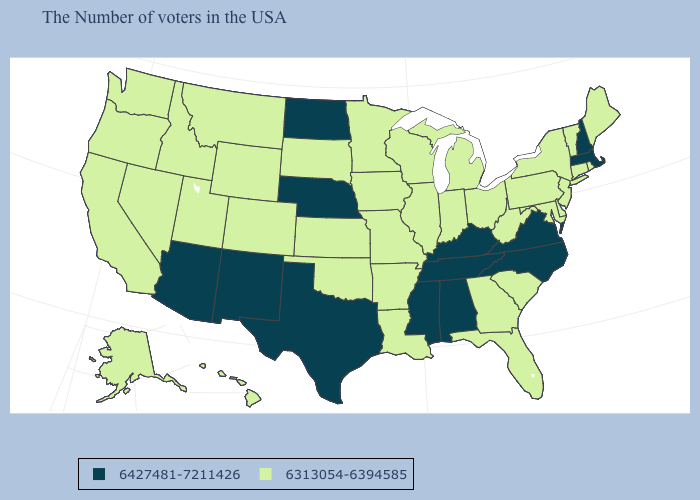Name the states that have a value in the range 6427481-7211426?
Concise answer only. Massachusetts, New Hampshire, Virginia, North Carolina, Kentucky, Alabama, Tennessee, Mississippi, Nebraska, Texas, North Dakota, New Mexico, Arizona. Which states have the highest value in the USA?
Write a very short answer. Massachusetts, New Hampshire, Virginia, North Carolina, Kentucky, Alabama, Tennessee, Mississippi, Nebraska, Texas, North Dakota, New Mexico, Arizona. Does Arkansas have the same value as Maryland?
Keep it brief. Yes. Name the states that have a value in the range 6427481-7211426?
Concise answer only. Massachusetts, New Hampshire, Virginia, North Carolina, Kentucky, Alabama, Tennessee, Mississippi, Nebraska, Texas, North Dakota, New Mexico, Arizona. What is the value of Wyoming?
Quick response, please. 6313054-6394585. Is the legend a continuous bar?
Give a very brief answer. No. What is the highest value in states that border Colorado?
Give a very brief answer. 6427481-7211426. Does the first symbol in the legend represent the smallest category?
Concise answer only. No. Name the states that have a value in the range 6427481-7211426?
Quick response, please. Massachusetts, New Hampshire, Virginia, North Carolina, Kentucky, Alabama, Tennessee, Mississippi, Nebraska, Texas, North Dakota, New Mexico, Arizona. What is the value of South Carolina?
Write a very short answer. 6313054-6394585. What is the value of Maryland?
Keep it brief. 6313054-6394585. What is the value of New York?
Concise answer only. 6313054-6394585. Does the first symbol in the legend represent the smallest category?
Give a very brief answer. No. What is the highest value in states that border Indiana?
Keep it brief. 6427481-7211426. What is the highest value in states that border Washington?
Be succinct. 6313054-6394585. 